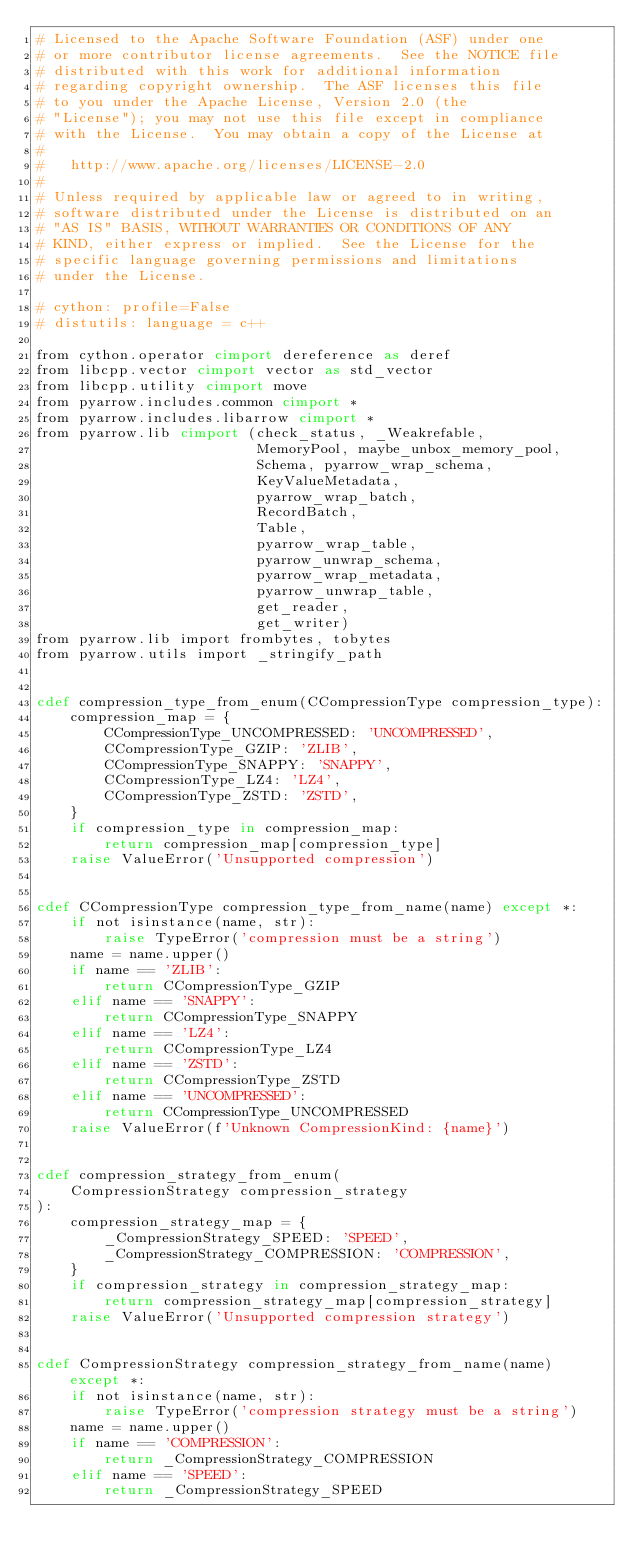Convert code to text. <code><loc_0><loc_0><loc_500><loc_500><_Cython_># Licensed to the Apache Software Foundation (ASF) under one
# or more contributor license agreements.  See the NOTICE file
# distributed with this work for additional information
# regarding copyright ownership.  The ASF licenses this file
# to you under the Apache License, Version 2.0 (the
# "License"); you may not use this file except in compliance
# with the License.  You may obtain a copy of the License at
#
#   http://www.apache.org/licenses/LICENSE-2.0
#
# Unless required by applicable law or agreed to in writing,
# software distributed under the License is distributed on an
# "AS IS" BASIS, WITHOUT WARRANTIES OR CONDITIONS OF ANY
# KIND, either express or implied.  See the License for the
# specific language governing permissions and limitations
# under the License.

# cython: profile=False
# distutils: language = c++

from cython.operator cimport dereference as deref
from libcpp.vector cimport vector as std_vector
from libcpp.utility cimport move
from pyarrow.includes.common cimport *
from pyarrow.includes.libarrow cimport *
from pyarrow.lib cimport (check_status, _Weakrefable,
                          MemoryPool, maybe_unbox_memory_pool,
                          Schema, pyarrow_wrap_schema,
                          KeyValueMetadata,
                          pyarrow_wrap_batch,
                          RecordBatch,
                          Table,
                          pyarrow_wrap_table,
                          pyarrow_unwrap_schema,
                          pyarrow_wrap_metadata,
                          pyarrow_unwrap_table,
                          get_reader,
                          get_writer)
from pyarrow.lib import frombytes, tobytes
from pyarrow.utils import _stringify_path


cdef compression_type_from_enum(CCompressionType compression_type):
    compression_map = {
        CCompressionType_UNCOMPRESSED: 'UNCOMPRESSED',
        CCompressionType_GZIP: 'ZLIB',
        CCompressionType_SNAPPY: 'SNAPPY',
        CCompressionType_LZ4: 'LZ4',
        CCompressionType_ZSTD: 'ZSTD',
    }
    if compression_type in compression_map:
        return compression_map[compression_type]
    raise ValueError('Unsupported compression')


cdef CCompressionType compression_type_from_name(name) except *:
    if not isinstance(name, str):
        raise TypeError('compression must be a string')
    name = name.upper()
    if name == 'ZLIB':
        return CCompressionType_GZIP
    elif name == 'SNAPPY':
        return CCompressionType_SNAPPY
    elif name == 'LZ4':
        return CCompressionType_LZ4
    elif name == 'ZSTD':
        return CCompressionType_ZSTD
    elif name == 'UNCOMPRESSED':
        return CCompressionType_UNCOMPRESSED
    raise ValueError(f'Unknown CompressionKind: {name}')


cdef compression_strategy_from_enum(
    CompressionStrategy compression_strategy
):
    compression_strategy_map = {
        _CompressionStrategy_SPEED: 'SPEED',
        _CompressionStrategy_COMPRESSION: 'COMPRESSION',
    }
    if compression_strategy in compression_strategy_map:
        return compression_strategy_map[compression_strategy]
    raise ValueError('Unsupported compression strategy')


cdef CompressionStrategy compression_strategy_from_name(name) except *:
    if not isinstance(name, str):
        raise TypeError('compression strategy must be a string')
    name = name.upper()
    if name == 'COMPRESSION':
        return _CompressionStrategy_COMPRESSION
    elif name == 'SPEED':
        return _CompressionStrategy_SPEED</code> 